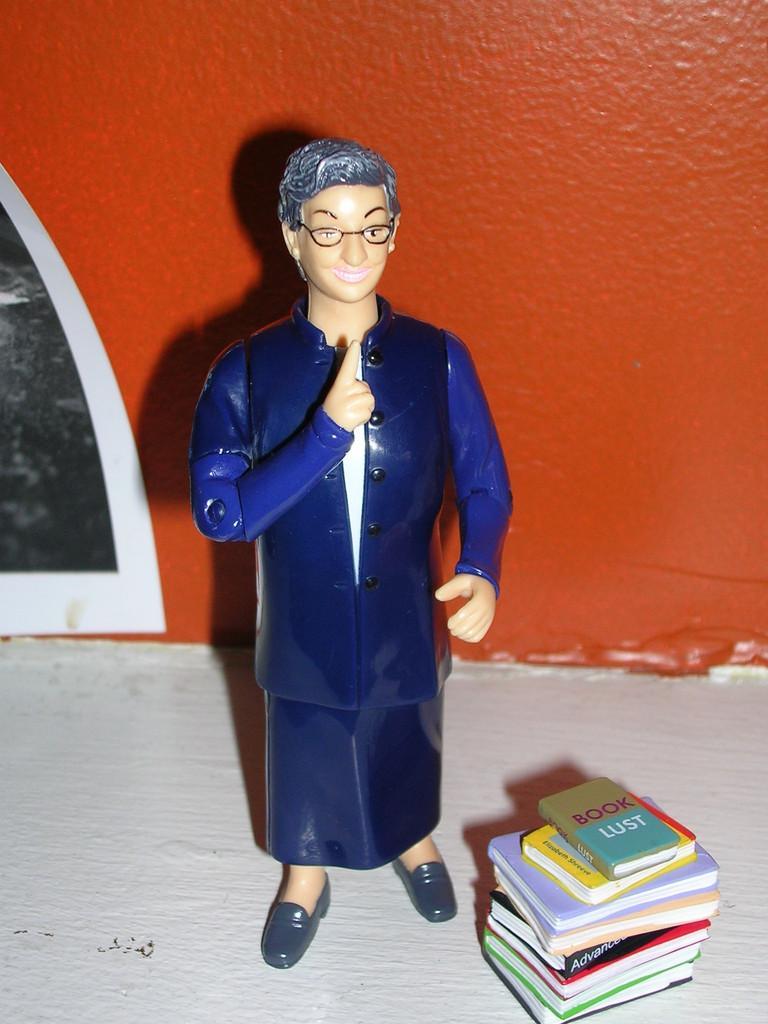Can you describe this image briefly? In this image, we can see a toy in front of the wall. There are books in the bottom right of the image. 